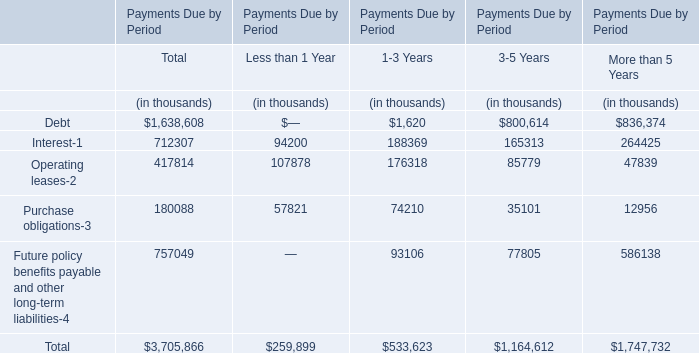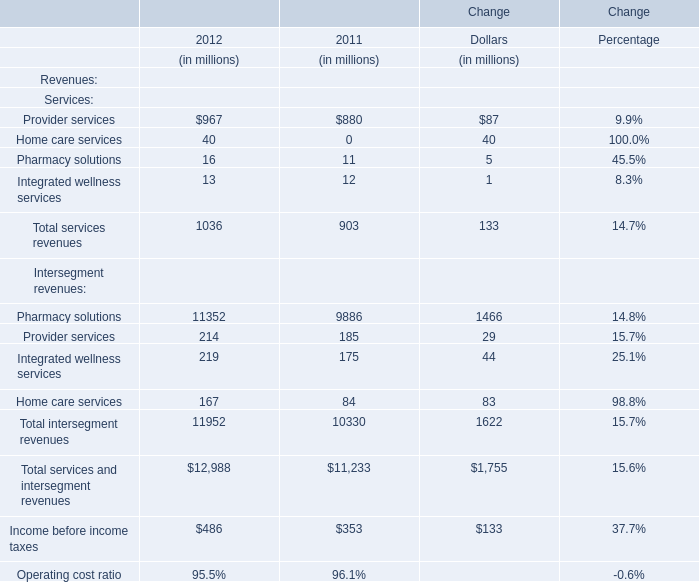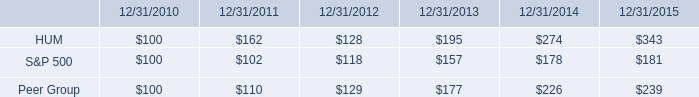as of december 30 , what was the number of stockholders of record 2015 in millions 
Computations: (43 / 0.29)
Answer: 148.27586. What is the proportion of Services:Provider services to the total in 2012 for Services? 
Computations: (967 / 1036)
Answer: 0.9334. 